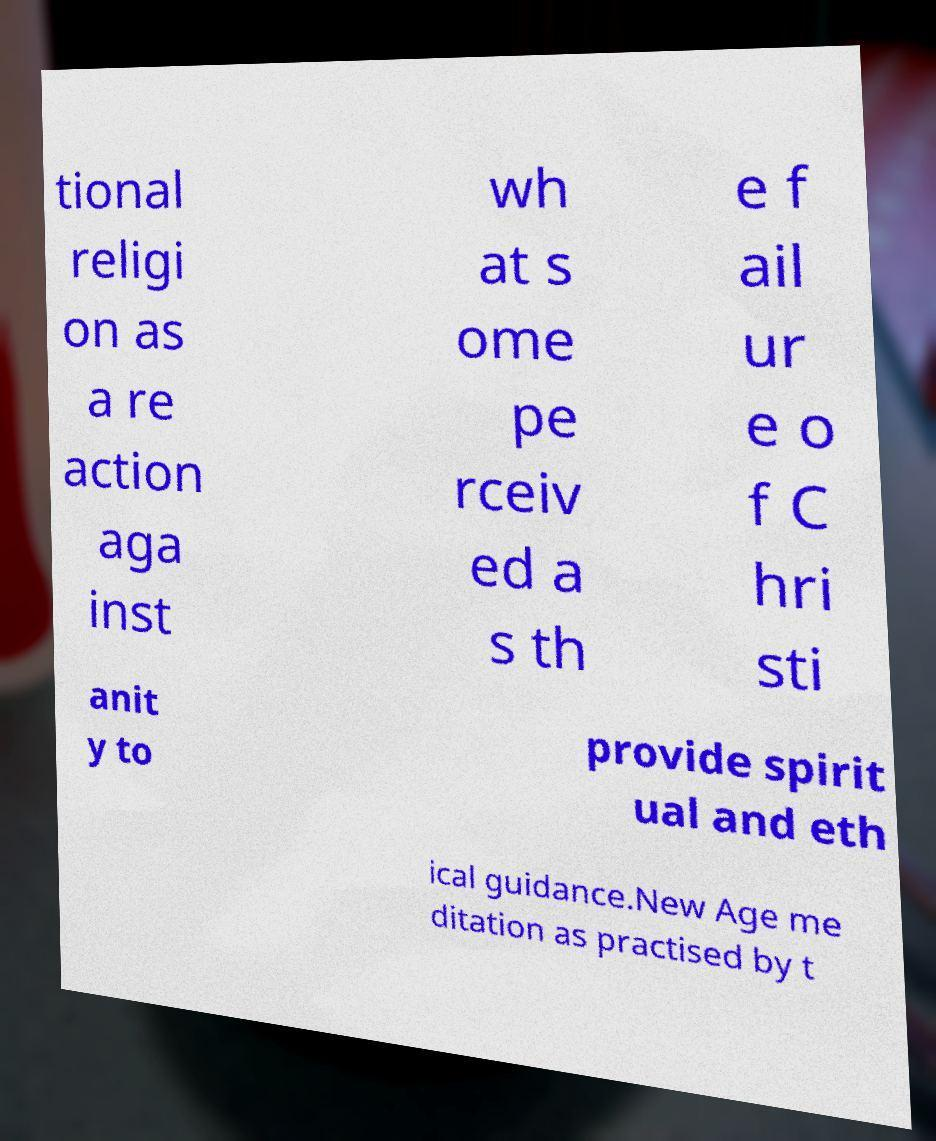Can you accurately transcribe the text from the provided image for me? tional religi on as a re action aga inst wh at s ome pe rceiv ed a s th e f ail ur e o f C hri sti anit y to provide spirit ual and eth ical guidance.New Age me ditation as practised by t 